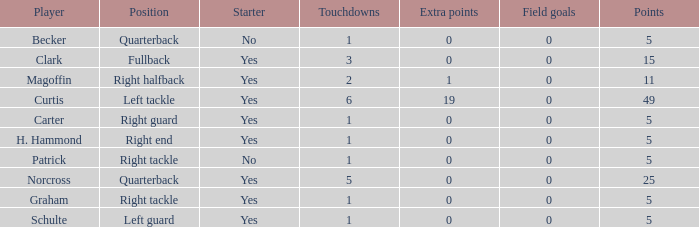Name the most touchdowns for becker  1.0. 